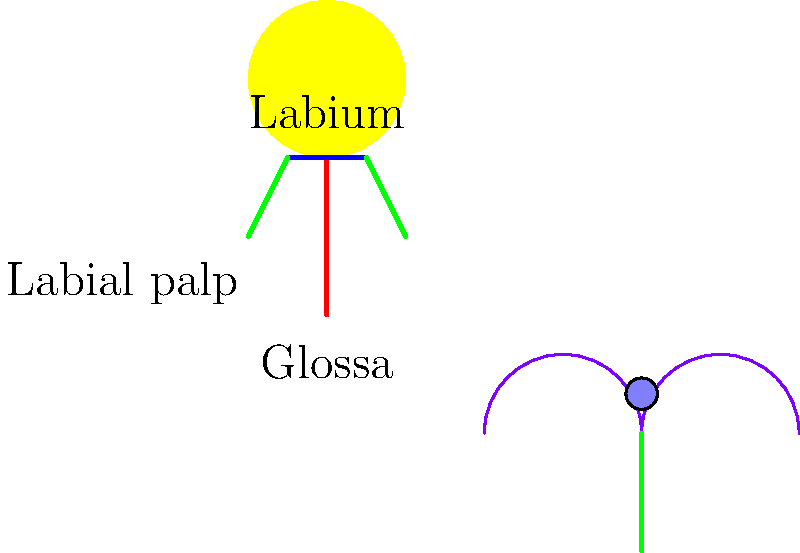Which component of a bee's proboscis is primarily responsible for sucking up nectar, and how does its structure contribute to efficient nectar collection? To understand the biomechanics of a bee's proboscis during nectar collection, let's break down the components and their functions:

1. Glossa (tongue): This is the long, central structure shown in red in the diagram. It's the primary component responsible for nectar collection.

2. Labium: Represented by the blue horizontal line, it serves as a support structure for the other components.

3. Labial palps: The green structures on either side, which help in sensing and manipulating the flower parts.

The glossa is specially adapted for nectar collection:

a) Structure: The glossa is covered in tiny, hair-like structures called microtrichia.

b) Function: These microtrichia create a large surface area that allows nectar to adhere to the tongue through capillary action.

c) Movement: The bee rapidly extends and retracts its glossa (up to 230 times per second), creating a pumping action.

d) Nectar flow: This rapid movement, combined with the microtrichia structure, allows nectar to flow up the tongue into the bee's mouth.

e) Efficiency: This mechanism enables bees to collect nectar much more efficiently than if they were to rely solely on suction.

The hairy structure and rapid movement of the glossa allow bees to collect nectar from flowers with varying nectar viscosities and depths, making them highly adaptable pollinators.
Answer: The glossa (tongue), with its hairy structure and rapid pumping motion. 